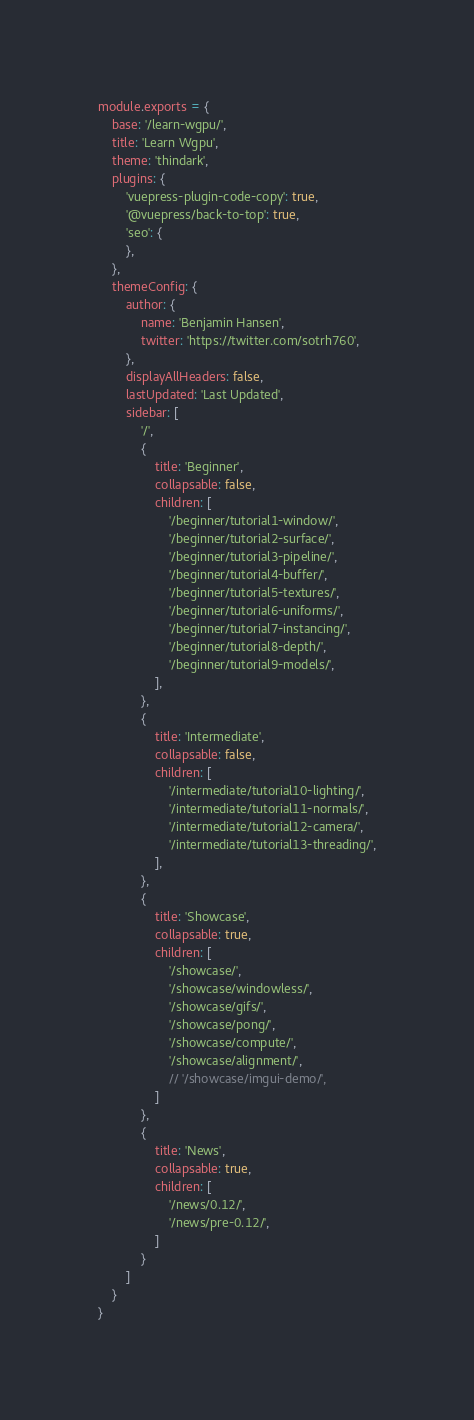Convert code to text. <code><loc_0><loc_0><loc_500><loc_500><_JavaScript_>module.exports = {
    base: '/learn-wgpu/',
    title: 'Learn Wgpu',
    theme: 'thindark',
    plugins: {
        'vuepress-plugin-code-copy': true,
        '@vuepress/back-to-top': true,
        'seo': {
        },
    },
    themeConfig: {
        author: {
            name: 'Benjamin Hansen',
            twitter: 'https://twitter.com/sotrh760',
        },
        displayAllHeaders: false,
        lastUpdated: 'Last Updated',
        sidebar: [
            '/',
            {
                title: 'Beginner',
                collapsable: false,
                children: [
                    '/beginner/tutorial1-window/',
                    '/beginner/tutorial2-surface/',
                    '/beginner/tutorial3-pipeline/',
                    '/beginner/tutorial4-buffer/',
                    '/beginner/tutorial5-textures/',
                    '/beginner/tutorial6-uniforms/',
                    '/beginner/tutorial7-instancing/',
                    '/beginner/tutorial8-depth/',
                    '/beginner/tutorial9-models/',
                ],
            },
            {
                title: 'Intermediate',
                collapsable: false,
                children: [
                    '/intermediate/tutorial10-lighting/',
                    '/intermediate/tutorial11-normals/',
                    '/intermediate/tutorial12-camera/',
                    '/intermediate/tutorial13-threading/',
                ],
            },
            {
                title: 'Showcase',
                collapsable: true,
                children: [
                    '/showcase/',
                    '/showcase/windowless/',
                    '/showcase/gifs/',
                    '/showcase/pong/',
                    '/showcase/compute/',
                    '/showcase/alignment/',
                    // '/showcase/imgui-demo/',
                ]
            },
            {
                title: 'News',
                collapsable: true,
                children: [
                    '/news/0.12/',
                    '/news/pre-0.12/',
                ]
            }
        ]
    }
}</code> 